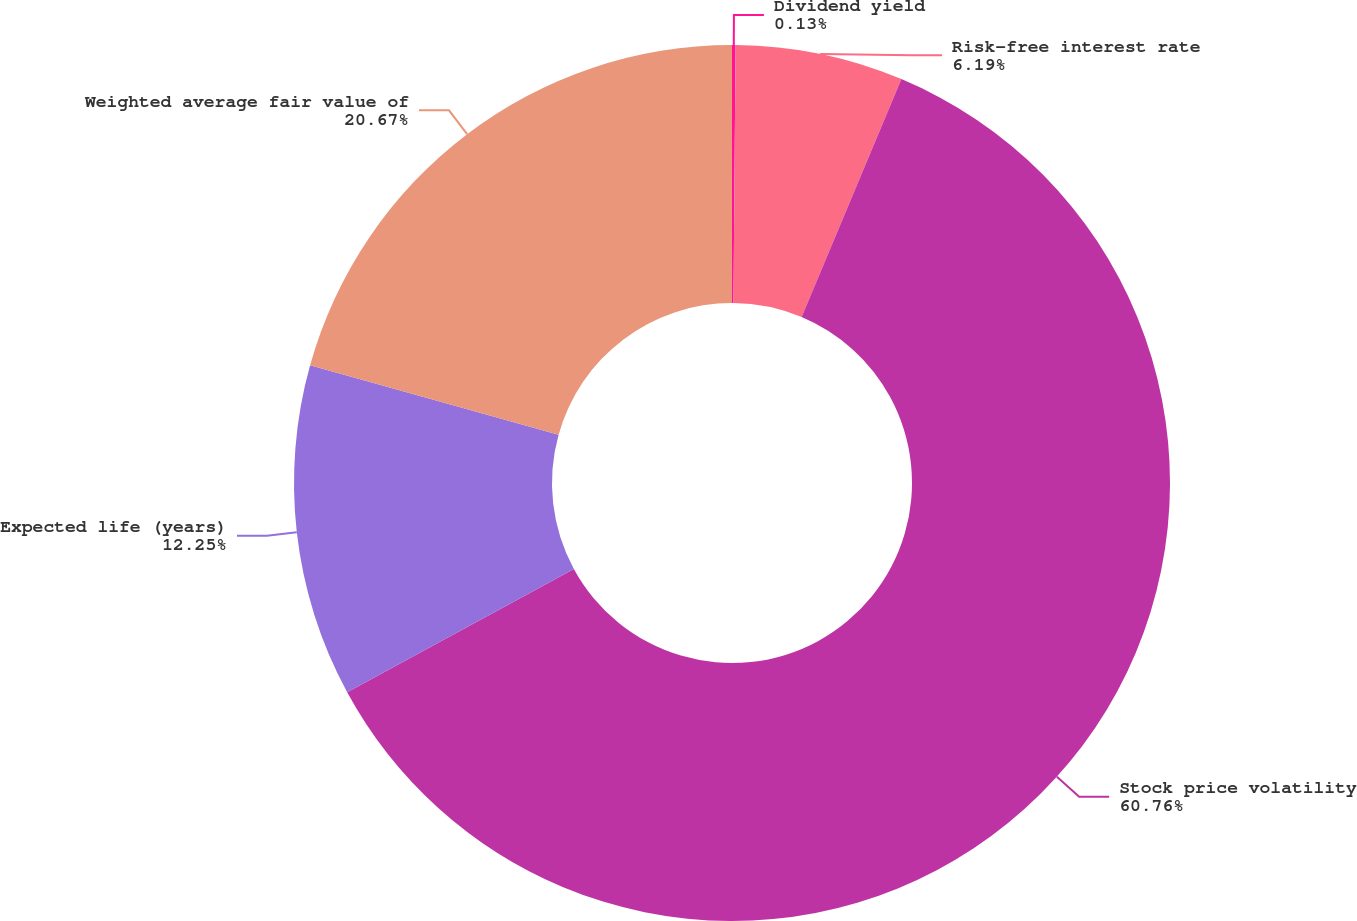Convert chart. <chart><loc_0><loc_0><loc_500><loc_500><pie_chart><fcel>Dividend yield<fcel>Risk-free interest rate<fcel>Stock price volatility<fcel>Expected life (years)<fcel>Weighted average fair value of<nl><fcel>0.13%<fcel>6.19%<fcel>60.75%<fcel>12.25%<fcel>20.67%<nl></chart> 